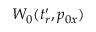Convert formula to latex. <formula><loc_0><loc_0><loc_500><loc_500>W _ { 0 } ( t _ { r } ^ { \prime } , p _ { 0 x } )</formula> 